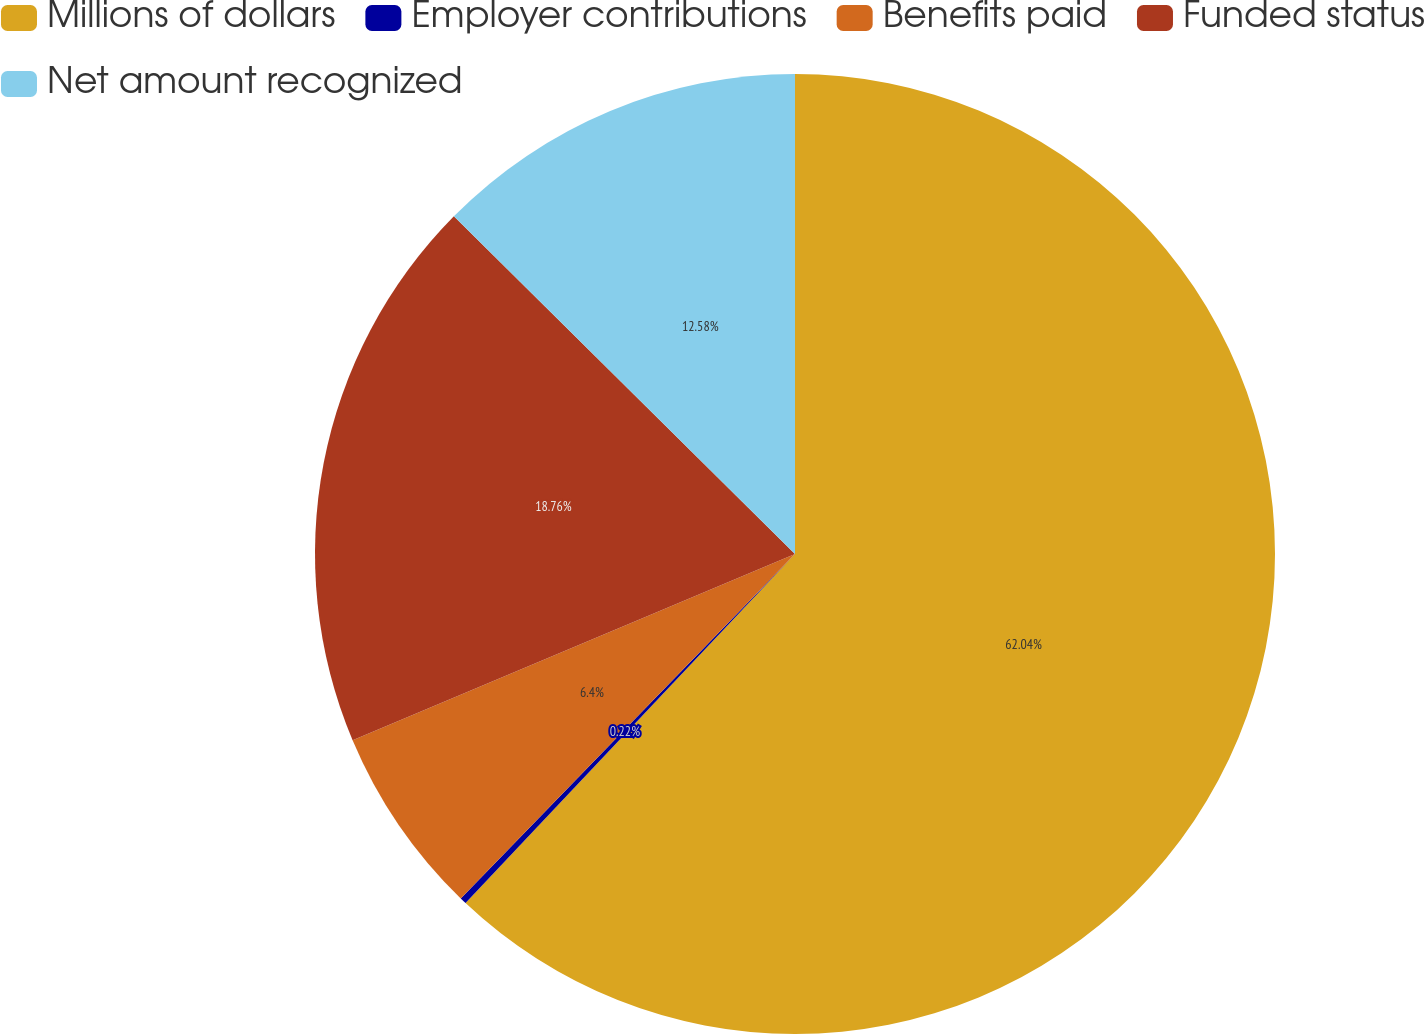Convert chart. <chart><loc_0><loc_0><loc_500><loc_500><pie_chart><fcel>Millions of dollars<fcel>Employer contributions<fcel>Benefits paid<fcel>Funded status<fcel>Net amount recognized<nl><fcel>62.04%<fcel>0.22%<fcel>6.4%<fcel>18.76%<fcel>12.58%<nl></chart> 